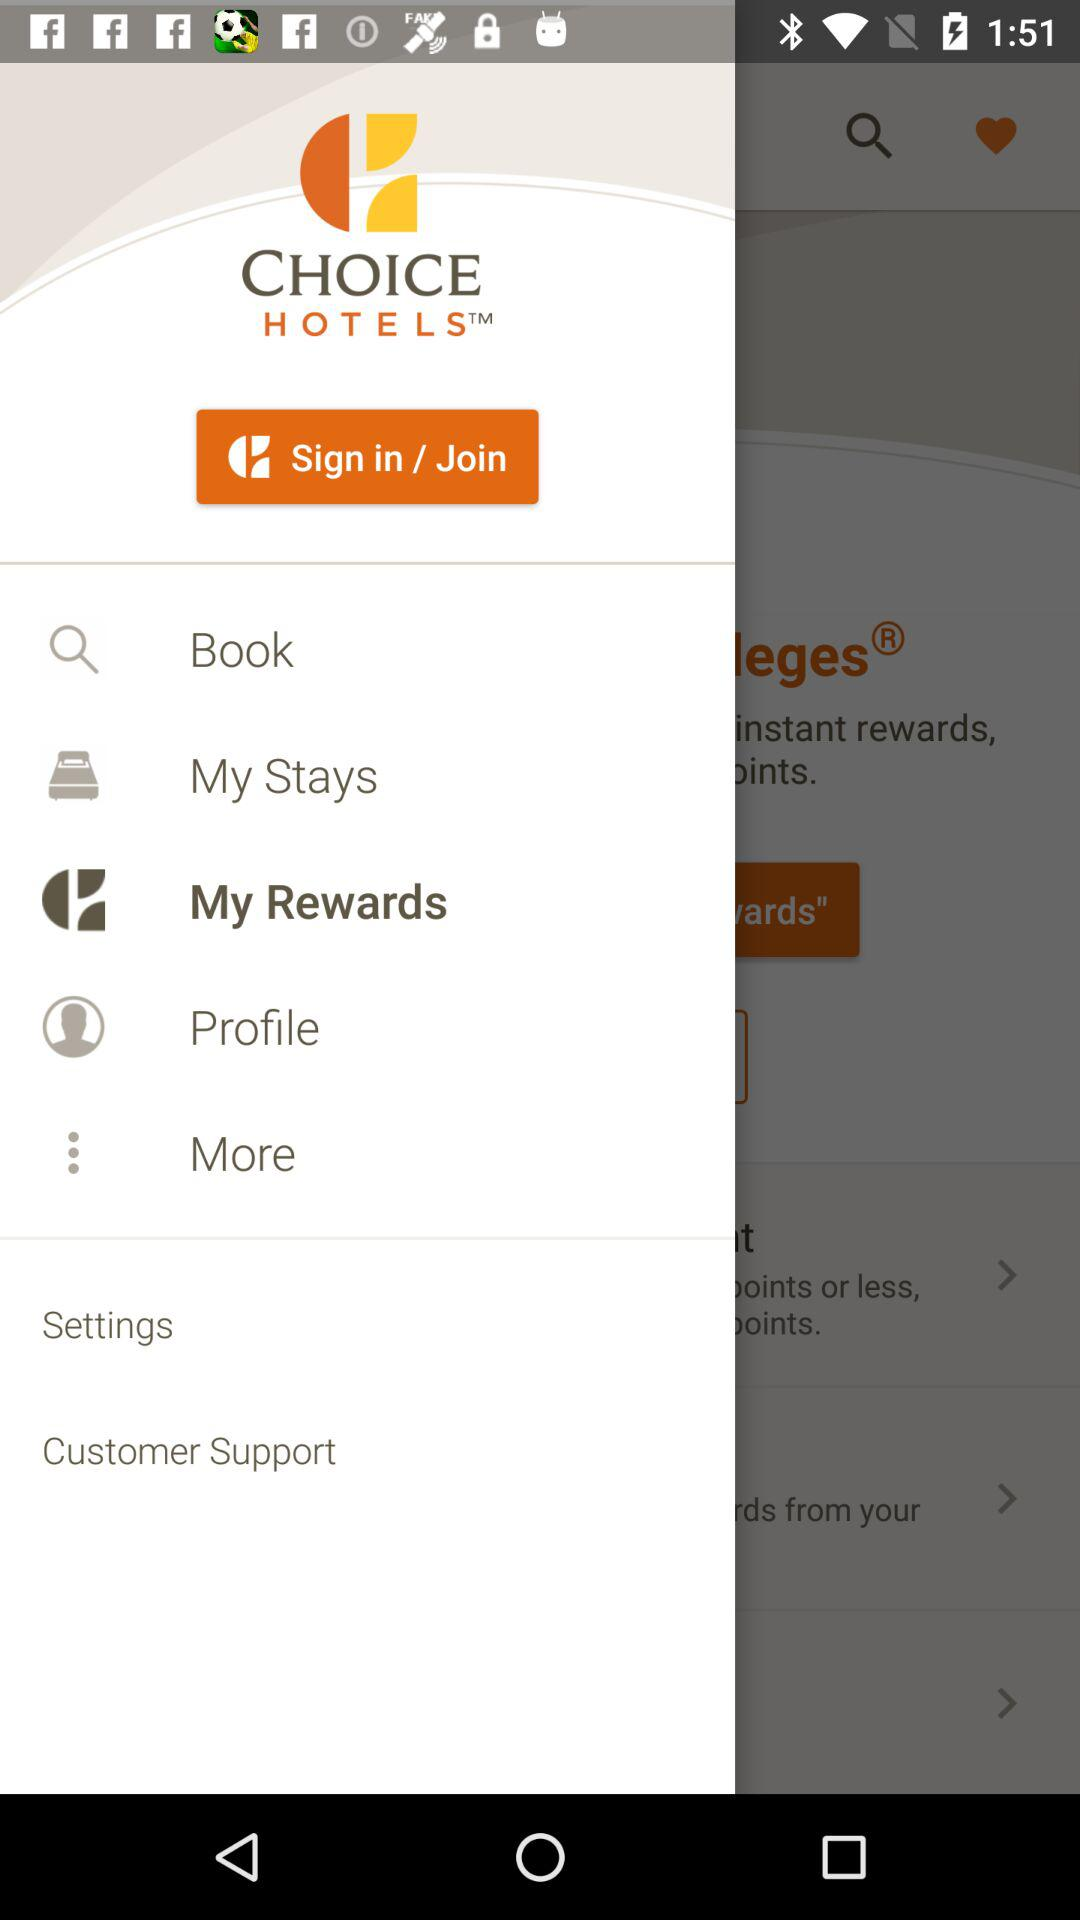What is the name of the application? The name of the application is "CHOICE HOTELS". 